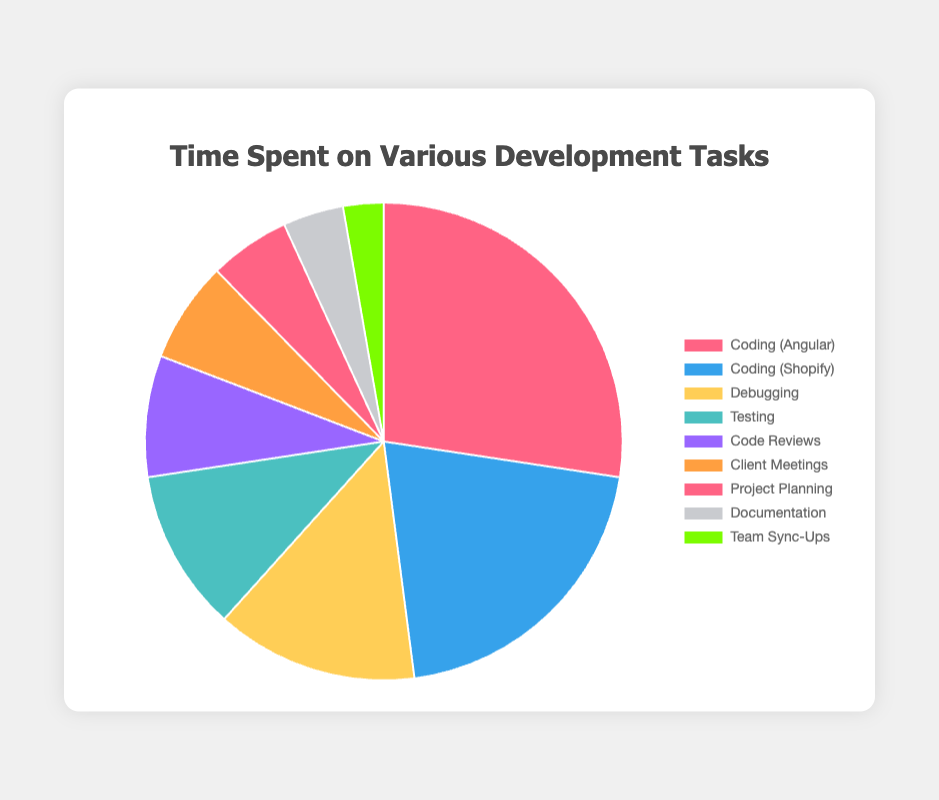Which task takes the most hours? The "Coding (Angular)" task has the largest slice in the pie chart, indicating it takes the most hours.
Answer: Coding (Angular) Which task takes the least hours? The "Team Sync-Ups" task has the smallest slice in the pie chart, indicating it takes the least hours.
Answer: Team Sync-Ups How many total hours are spent on coding tasks? Add the hours spent on "Coding (Angular)" and "Coding (Shopify)": 20 + 15 = 35.
Answer: 35 What percentage of the total time is spent on debugging? The "Debugging" slice represents 10 hours. The total is 73 hours. The percentage is (10/73) * 100 ≈ 13.7%
Answer: 13.7% Which two tasks take the same amount of hours, and how many hours do they take? "Coding (Angular)" and "Coding (Shopify)" have different hours. None of the tasks take exactly the same amount of hours.
Answer: None Which task group has more hours, "Client Meetings" or "Documentation"? Compare the "Client Meetings" slice (5 hours) to the "Documentation" slice (3 hours). "Client Meetings" has more hours.
Answer: Client Meetings How many more hours are spent on testing compared to team sync-ups? Subtract the hours for "Team Sync-Ups" from "Testing": 8 - 2 = 6 hours.
Answer: 6 What is the average number of hours spent per task? Total hours are 73. There are 9 tasks. The average is 73 / 9 ≈ 8.1 hours.
Answer: 8.1 Which color represents the "Code Reviews" task? The "Code Reviews" task is represented by the purple slice.
Answer: Purple How many tasks take more than 5 hours each? Count the tasks with hours greater than 5: "Coding (Angular)", "Coding (Shopify)", "Debugging", and "Testing". There are 4 such tasks.
Answer: 4 